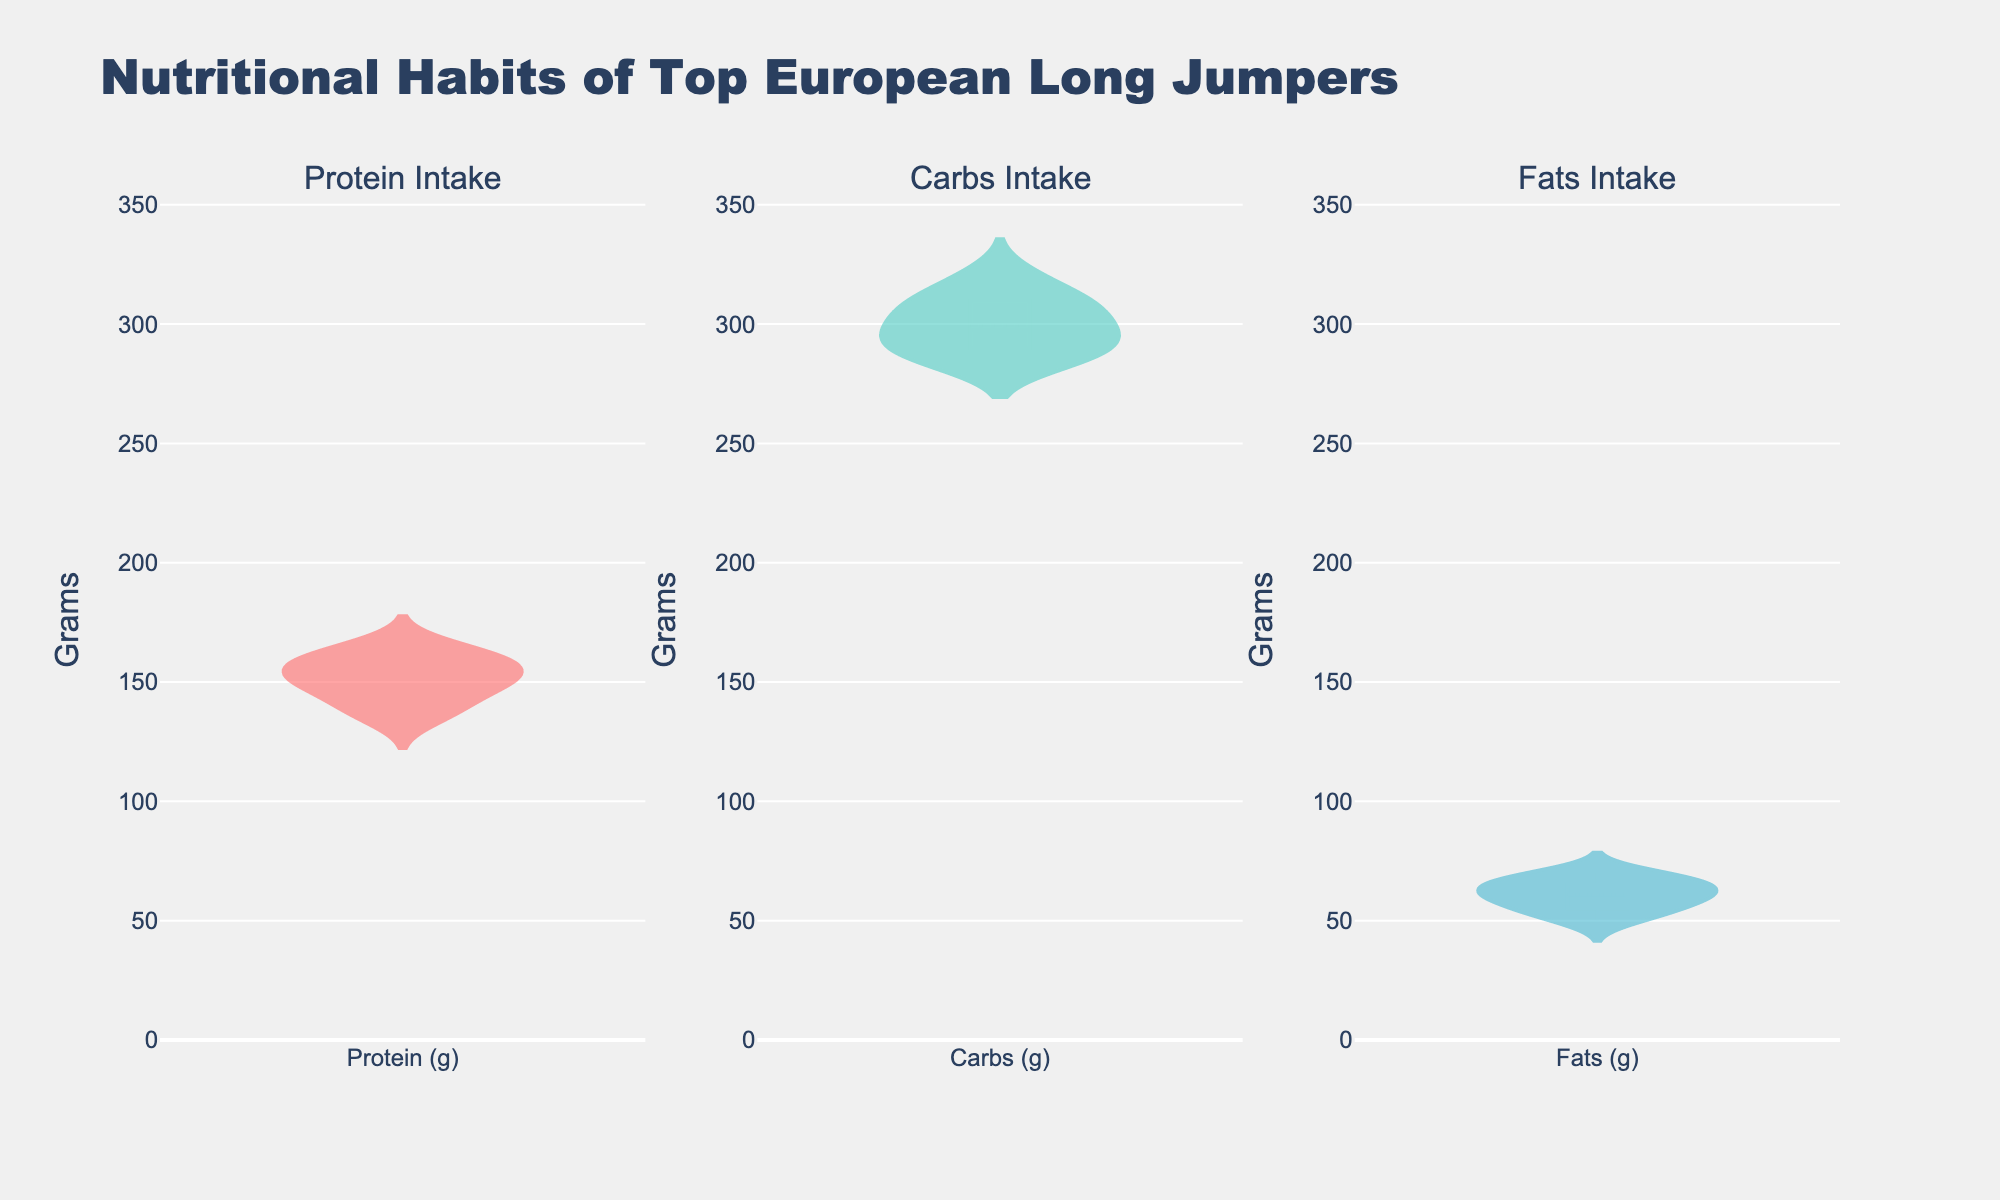What is the title of the figure? The title is usually displayed at the top of the figure, clearly indicating what information the chart is representing.
Answer: Nutritional Habits of Top European Long Jumpers How many categories of nutrients are being compared in the figure? The title and subplot titles indicate that three different nutrient categories are being compared. Each subplot represents one category.
Answer: 3 Which nutrient has the lowest median intake among the top-performing long jumpers? The median is typically represented by the line inside the box of a violin plot. By examining the three subplots, we can compare the positions of these median lines.
Answer: Fats Which nutrient shows the largest variation in intake among the athletes? Variation can be judged by the width of the violin plot. The wider the plot, the more variation there is. Comparing the three plots, we can identify the one with the widest spread.
Answer: Carbs How does the interquartile range (IQR) of protein intake compare to that of fat intake? The IQR is the range between the lower quartile and the upper quartile, which can be identified by examining the range of the box within each violin plot. We need to visually compare the boxes in the protein and fats subplots.
Answer: Protein has a wider IQR than Fats Are there any outliers in the protein intake among the long jumpers? Outliers in violin plots are typically represented by points outside the main bulk of the data. By examining the protein intake subplot, we can check if there are any isolated points.
Answer: No Which athlete's diet is closest to the average values depicted for carbohydrate intake? The mean line is displayed in each violin plot, representing the average. Checking the position relative to individual data points can help identify the closest athlete. We then reference back to the data provided to match the values.
Answer: Radek Juška Is there more consistency in fat intake or protein intake across athletes? Consistency can be seen by the narrowness of the violin plot indicating less variation. Comparing the shapes of the violin plots for fats and protein will determine which is more consistent.
Answer: Fats What is the range of carbohydrate intake among the athletes? The range in a violin plot can be seen by identifying the highest and lowest points within the plot. Looking at the carbs subplot allows us to determine this range.
Answer: 285 - 320 grams Are the top-performing long jumpers' diets balanced in terms of nutrient intake according to the figure? To determine if diets are balanced, we look for similar ranges, medians, and variations across the three nutrients represented.
Answer: No, there is more variation in carbs intake compared to protein and fats 